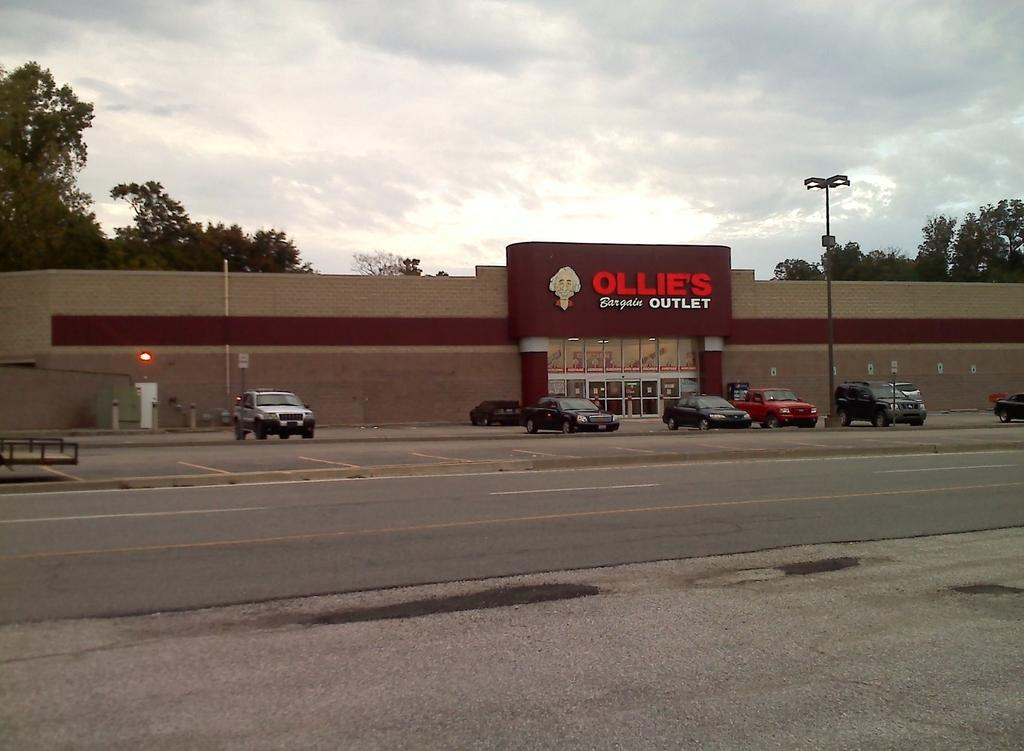What is the main feature of the image? There is a road in the image. What can be seen near the road? There are cars parked in front of a building. What is present in the image besides the road and cars? There is a pole in the image. What can be seen in the background of the image? There are trees and the sky visible in the background of the image. What is the condition of the sky in the image? The sky has clouds in the image. What type of office can be seen in the image? There is no office present in the image; it features a road, cars, a pole, trees, and a sky with clouds. What are the hands of the person in the image doing? There is no person present in the image, so there are no hands to describe. 